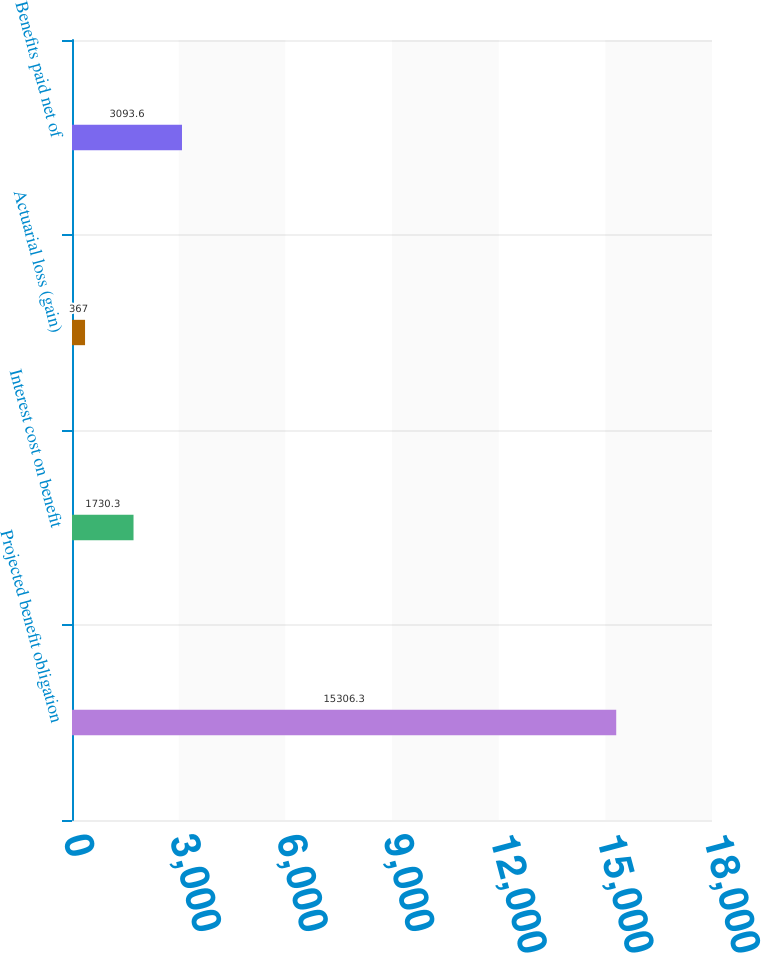Convert chart to OTSL. <chart><loc_0><loc_0><loc_500><loc_500><bar_chart><fcel>Projected benefit obligation<fcel>Interest cost on benefit<fcel>Actuarial loss (gain)<fcel>Benefits paid net of<nl><fcel>15306.3<fcel>1730.3<fcel>367<fcel>3093.6<nl></chart> 